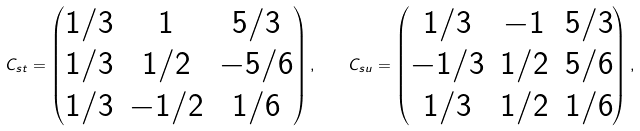Convert formula to latex. <formula><loc_0><loc_0><loc_500><loc_500>C _ { s t } = \begin{pmatrix} 1 / 3 & 1 & { 5 } / { 3 } \\ 1 / 3 & 1 / 2 & - { 5 } / { 6 } \\ 1 / 3 & - 1 / 2 & 1 / { 6 } \end{pmatrix} , \quad C _ { s u } = \begin{pmatrix} 1 / { 3 } & - 1 & { 5 } / { 3 } \\ - 1 / { 3 } & 1 / { 2 } & { 5 } / { 6 } \\ 1 / { 3 } & 1 / { 2 } & 1 / { 6 } \end{pmatrix} ,</formula> 